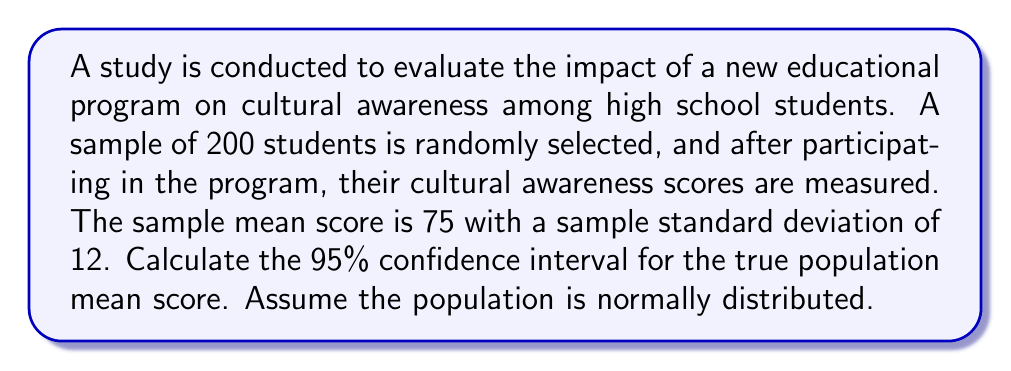Could you help me with this problem? To calculate the confidence interval, we'll follow these steps:

1. Identify the given information:
   - Sample size (n) = 200
   - Sample mean ($\bar{x}$) = 75
   - Sample standard deviation (s) = 12
   - Confidence level = 95%

2. Determine the critical value (z-score) for a 95% confidence level:
   The z-score for a 95% confidence level is 1.96.

3. Calculate the standard error (SE) of the mean:
   $$SE = \frac{s}{\sqrt{n}} = \frac{12}{\sqrt{200}} = \frac{12}{14.14} = 0.85$$

4. Calculate the margin of error (ME):
   $$ME = z \cdot SE = 1.96 \cdot 0.85 = 1.67$$

5. Compute the confidence interval:
   Lower bound: $\bar{x} - ME = 75 - 1.67 = 73.33$
   Upper bound: $\bar{x} + ME = 75 + 1.67 = 76.67$

Therefore, the 95% confidence interval for the true population mean score is (73.33, 76.67).

This means we can be 95% confident that the true population mean cultural awareness score falls between 73.33 and 76.67.
Answer: (73.33, 76.67) 